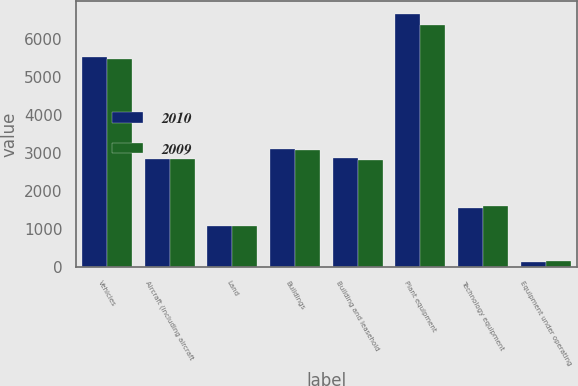Convert chart. <chart><loc_0><loc_0><loc_500><loc_500><stacked_bar_chart><ecel><fcel>Vehicles<fcel>Aircraft (including aircraft<fcel>Land<fcel>Buildings<fcel>Building and leasehold<fcel>Plant equipment<fcel>Technology equipment<fcel>Equipment under operating<nl><fcel>2010<fcel>5519<fcel>2830<fcel>1081<fcel>3102<fcel>2860<fcel>6656<fcel>1552<fcel>122<nl><fcel>2009<fcel>5480<fcel>2830<fcel>1079<fcel>3076<fcel>2800<fcel>6371<fcel>1591<fcel>145<nl></chart> 